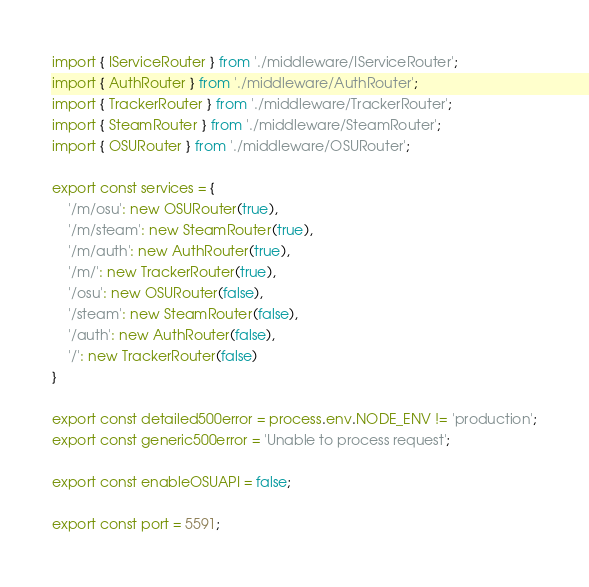<code> <loc_0><loc_0><loc_500><loc_500><_TypeScript_>import { IServiceRouter } from './middleware/IServiceRouter';
import { AuthRouter } from './middleware/AuthRouter';
import { TrackerRouter } from './middleware/TrackerRouter';
import { SteamRouter } from './middleware/SteamRouter';
import { OSURouter } from './middleware/OSURouter';

export const services = {
    '/m/osu': new OSURouter(true),
    '/m/steam': new SteamRouter(true),
    '/m/auth': new AuthRouter(true),
    '/m/': new TrackerRouter(true),
    '/osu': new OSURouter(false),
    '/steam': new SteamRouter(false),
    '/auth': new AuthRouter(false),
    '/': new TrackerRouter(false)
}

export const detailed500error = process.env.NODE_ENV != 'production';
export const generic500error = 'Unable to process request';

export const enableOSUAPI = false;

export const port = 5591;</code> 